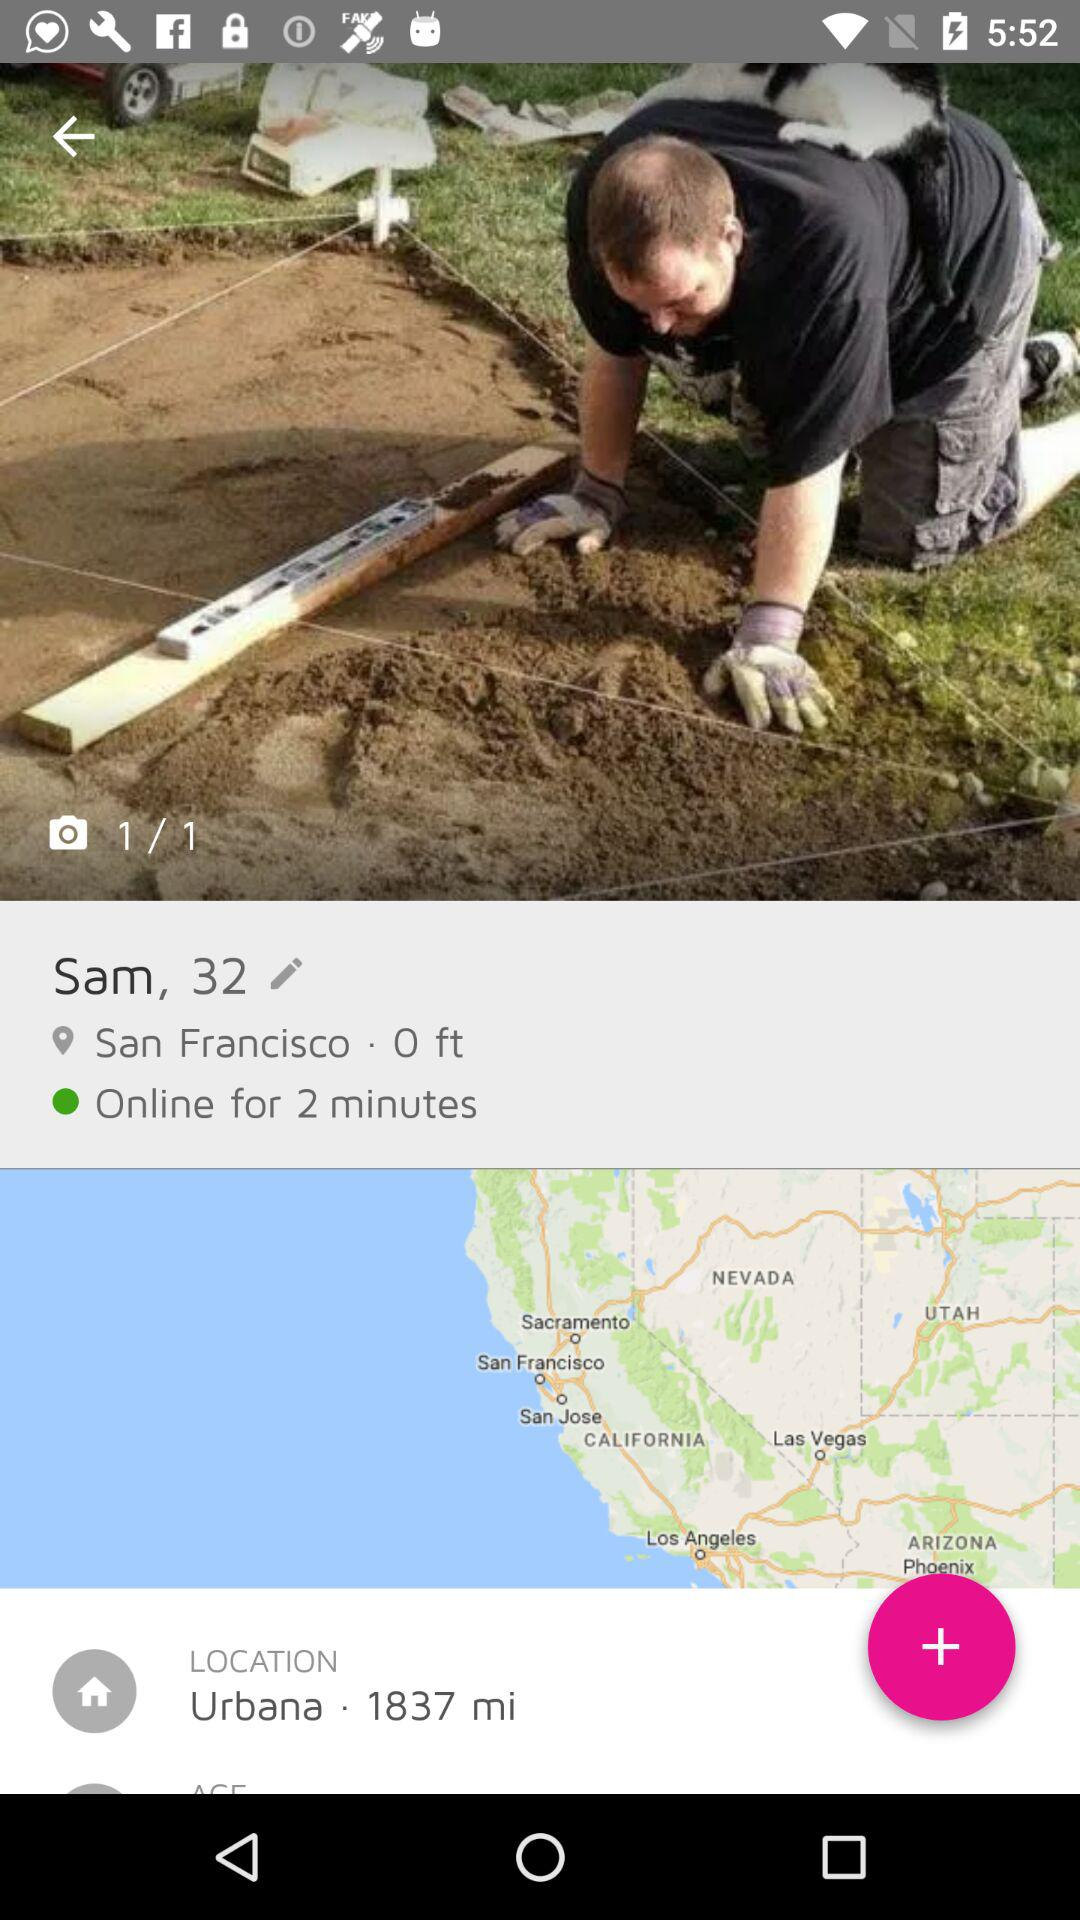What is the location? The locations are San Francisco and Urbana. 